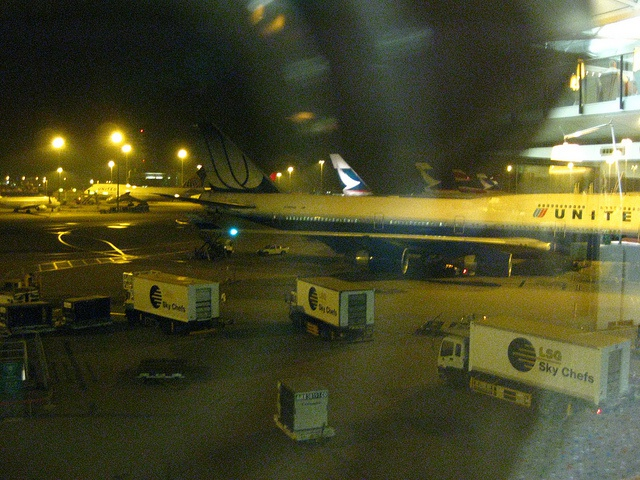Describe the objects in this image and their specific colors. I can see airplane in black, gold, and olive tones, truck in black, olive, and gray tones, truck in black, olive, and darkgreen tones, truck in black, olive, and darkgreen tones, and airplane in black, olive, gray, and white tones in this image. 